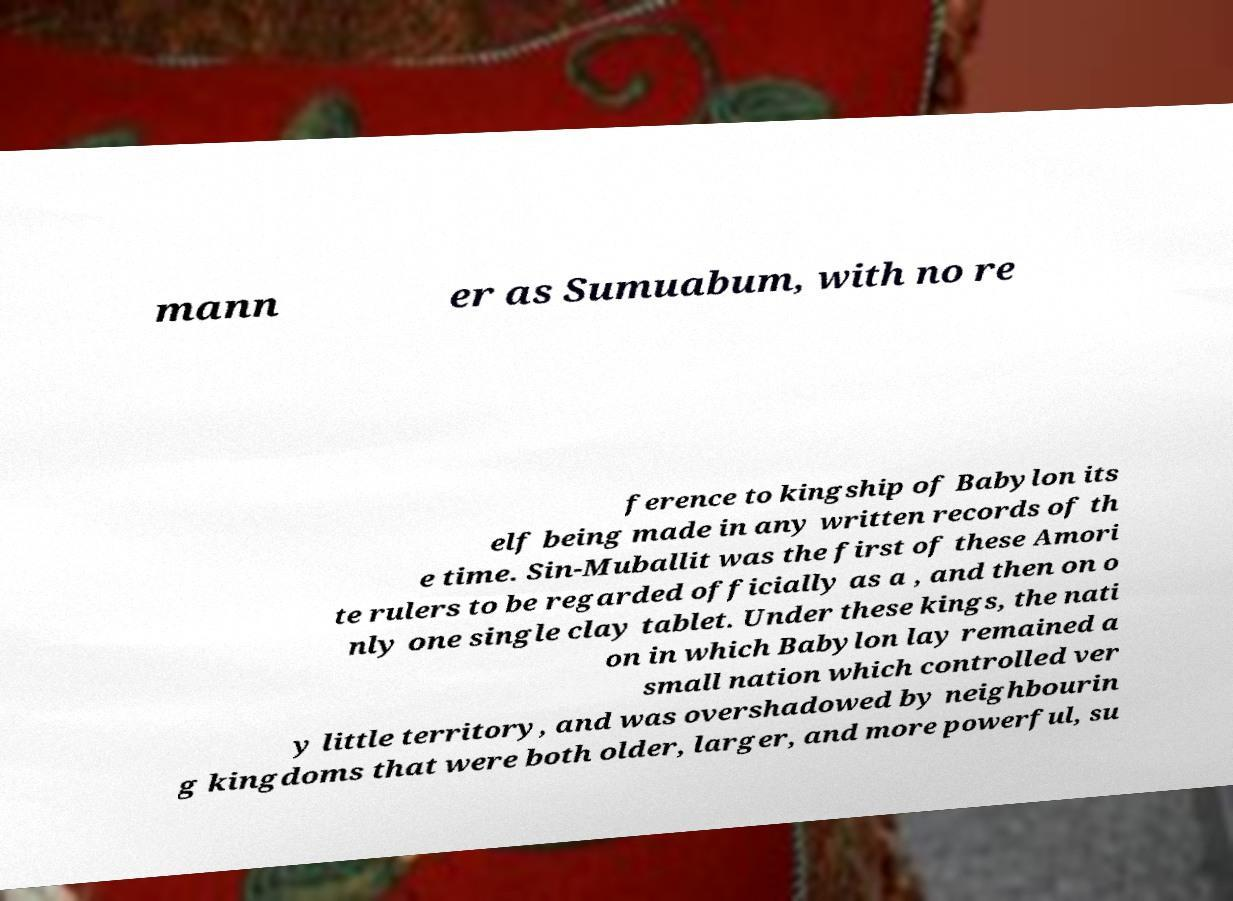There's text embedded in this image that I need extracted. Can you transcribe it verbatim? mann er as Sumuabum, with no re ference to kingship of Babylon its elf being made in any written records of th e time. Sin-Muballit was the first of these Amori te rulers to be regarded officially as a , and then on o nly one single clay tablet. Under these kings, the nati on in which Babylon lay remained a small nation which controlled ver y little territory, and was overshadowed by neighbourin g kingdoms that were both older, larger, and more powerful, su 